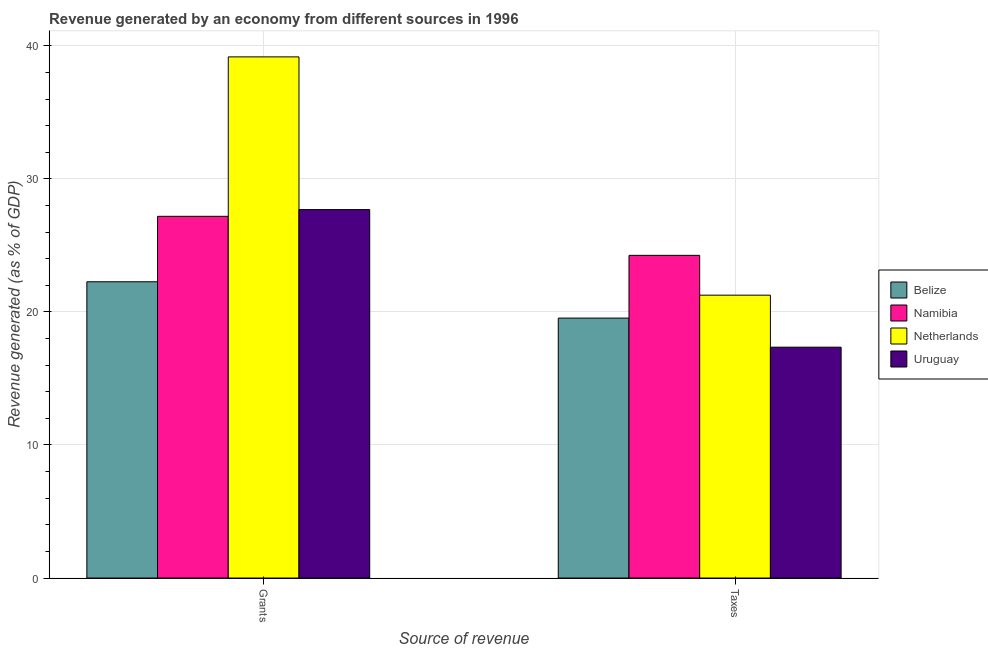What is the label of the 2nd group of bars from the left?
Keep it short and to the point. Taxes. What is the revenue generated by taxes in Namibia?
Make the answer very short. 24.25. Across all countries, what is the maximum revenue generated by taxes?
Make the answer very short. 24.25. Across all countries, what is the minimum revenue generated by taxes?
Ensure brevity in your answer.  17.35. In which country was the revenue generated by taxes maximum?
Your answer should be very brief. Namibia. In which country was the revenue generated by grants minimum?
Your answer should be very brief. Belize. What is the total revenue generated by grants in the graph?
Your answer should be compact. 116.32. What is the difference between the revenue generated by taxes in Belize and that in Namibia?
Provide a short and direct response. -4.71. What is the difference between the revenue generated by grants in Namibia and the revenue generated by taxes in Uruguay?
Your answer should be very brief. 9.84. What is the average revenue generated by taxes per country?
Your response must be concise. 20.6. What is the difference between the revenue generated by grants and revenue generated by taxes in Netherlands?
Your response must be concise. 17.91. What is the ratio of the revenue generated by grants in Belize to that in Netherlands?
Give a very brief answer. 0.57. Is the revenue generated by grants in Belize less than that in Uruguay?
Ensure brevity in your answer.  Yes. What does the 2nd bar from the left in Grants represents?
Offer a terse response. Namibia. What does the 3rd bar from the right in Taxes represents?
Your response must be concise. Namibia. How many bars are there?
Offer a terse response. 8. Are all the bars in the graph horizontal?
Provide a succinct answer. No. What is the difference between two consecutive major ticks on the Y-axis?
Keep it short and to the point. 10. Are the values on the major ticks of Y-axis written in scientific E-notation?
Ensure brevity in your answer.  No. Does the graph contain any zero values?
Provide a succinct answer. No. Does the graph contain grids?
Provide a short and direct response. Yes. How are the legend labels stacked?
Give a very brief answer. Vertical. What is the title of the graph?
Ensure brevity in your answer.  Revenue generated by an economy from different sources in 1996. Does "Middle East & North Africa (developing only)" appear as one of the legend labels in the graph?
Offer a very short reply. No. What is the label or title of the X-axis?
Provide a short and direct response. Source of revenue. What is the label or title of the Y-axis?
Provide a succinct answer. Revenue generated (as % of GDP). What is the Revenue generated (as % of GDP) of Belize in Grants?
Offer a terse response. 22.27. What is the Revenue generated (as % of GDP) of Namibia in Grants?
Give a very brief answer. 27.19. What is the Revenue generated (as % of GDP) in Netherlands in Grants?
Your answer should be very brief. 39.17. What is the Revenue generated (as % of GDP) in Uruguay in Grants?
Keep it short and to the point. 27.69. What is the Revenue generated (as % of GDP) in Belize in Taxes?
Ensure brevity in your answer.  19.54. What is the Revenue generated (as % of GDP) of Namibia in Taxes?
Give a very brief answer. 24.25. What is the Revenue generated (as % of GDP) of Netherlands in Taxes?
Keep it short and to the point. 21.26. What is the Revenue generated (as % of GDP) of Uruguay in Taxes?
Provide a succinct answer. 17.35. Across all Source of revenue, what is the maximum Revenue generated (as % of GDP) in Belize?
Your response must be concise. 22.27. Across all Source of revenue, what is the maximum Revenue generated (as % of GDP) in Namibia?
Keep it short and to the point. 27.19. Across all Source of revenue, what is the maximum Revenue generated (as % of GDP) in Netherlands?
Make the answer very short. 39.17. Across all Source of revenue, what is the maximum Revenue generated (as % of GDP) of Uruguay?
Offer a very short reply. 27.69. Across all Source of revenue, what is the minimum Revenue generated (as % of GDP) of Belize?
Give a very brief answer. 19.54. Across all Source of revenue, what is the minimum Revenue generated (as % of GDP) of Namibia?
Offer a terse response. 24.25. Across all Source of revenue, what is the minimum Revenue generated (as % of GDP) of Netherlands?
Offer a terse response. 21.26. Across all Source of revenue, what is the minimum Revenue generated (as % of GDP) of Uruguay?
Your response must be concise. 17.35. What is the total Revenue generated (as % of GDP) of Belize in the graph?
Give a very brief answer. 41.81. What is the total Revenue generated (as % of GDP) of Namibia in the graph?
Offer a very short reply. 51.44. What is the total Revenue generated (as % of GDP) in Netherlands in the graph?
Ensure brevity in your answer.  60.43. What is the total Revenue generated (as % of GDP) in Uruguay in the graph?
Provide a succinct answer. 45.04. What is the difference between the Revenue generated (as % of GDP) in Belize in Grants and that in Taxes?
Make the answer very short. 2.73. What is the difference between the Revenue generated (as % of GDP) of Namibia in Grants and that in Taxes?
Ensure brevity in your answer.  2.93. What is the difference between the Revenue generated (as % of GDP) of Netherlands in Grants and that in Taxes?
Offer a very short reply. 17.91. What is the difference between the Revenue generated (as % of GDP) in Uruguay in Grants and that in Taxes?
Offer a terse response. 10.34. What is the difference between the Revenue generated (as % of GDP) in Belize in Grants and the Revenue generated (as % of GDP) in Namibia in Taxes?
Your response must be concise. -1.99. What is the difference between the Revenue generated (as % of GDP) in Belize in Grants and the Revenue generated (as % of GDP) in Uruguay in Taxes?
Ensure brevity in your answer.  4.92. What is the difference between the Revenue generated (as % of GDP) of Namibia in Grants and the Revenue generated (as % of GDP) of Netherlands in Taxes?
Ensure brevity in your answer.  5.93. What is the difference between the Revenue generated (as % of GDP) in Namibia in Grants and the Revenue generated (as % of GDP) in Uruguay in Taxes?
Make the answer very short. 9.84. What is the difference between the Revenue generated (as % of GDP) of Netherlands in Grants and the Revenue generated (as % of GDP) of Uruguay in Taxes?
Offer a terse response. 21.82. What is the average Revenue generated (as % of GDP) of Belize per Source of revenue?
Keep it short and to the point. 20.9. What is the average Revenue generated (as % of GDP) of Namibia per Source of revenue?
Give a very brief answer. 25.72. What is the average Revenue generated (as % of GDP) of Netherlands per Source of revenue?
Keep it short and to the point. 30.22. What is the average Revenue generated (as % of GDP) in Uruguay per Source of revenue?
Your response must be concise. 22.52. What is the difference between the Revenue generated (as % of GDP) in Belize and Revenue generated (as % of GDP) in Namibia in Grants?
Offer a terse response. -4.92. What is the difference between the Revenue generated (as % of GDP) in Belize and Revenue generated (as % of GDP) in Netherlands in Grants?
Offer a terse response. -16.9. What is the difference between the Revenue generated (as % of GDP) of Belize and Revenue generated (as % of GDP) of Uruguay in Grants?
Your response must be concise. -5.42. What is the difference between the Revenue generated (as % of GDP) of Namibia and Revenue generated (as % of GDP) of Netherlands in Grants?
Offer a terse response. -11.98. What is the difference between the Revenue generated (as % of GDP) of Namibia and Revenue generated (as % of GDP) of Uruguay in Grants?
Offer a terse response. -0.51. What is the difference between the Revenue generated (as % of GDP) in Netherlands and Revenue generated (as % of GDP) in Uruguay in Grants?
Provide a succinct answer. 11.48. What is the difference between the Revenue generated (as % of GDP) in Belize and Revenue generated (as % of GDP) in Namibia in Taxes?
Offer a terse response. -4.71. What is the difference between the Revenue generated (as % of GDP) of Belize and Revenue generated (as % of GDP) of Netherlands in Taxes?
Give a very brief answer. -1.72. What is the difference between the Revenue generated (as % of GDP) in Belize and Revenue generated (as % of GDP) in Uruguay in Taxes?
Ensure brevity in your answer.  2.19. What is the difference between the Revenue generated (as % of GDP) in Namibia and Revenue generated (as % of GDP) in Netherlands in Taxes?
Your response must be concise. 2.99. What is the difference between the Revenue generated (as % of GDP) of Namibia and Revenue generated (as % of GDP) of Uruguay in Taxes?
Provide a short and direct response. 6.9. What is the difference between the Revenue generated (as % of GDP) in Netherlands and Revenue generated (as % of GDP) in Uruguay in Taxes?
Your answer should be compact. 3.91. What is the ratio of the Revenue generated (as % of GDP) of Belize in Grants to that in Taxes?
Your response must be concise. 1.14. What is the ratio of the Revenue generated (as % of GDP) in Namibia in Grants to that in Taxes?
Provide a short and direct response. 1.12. What is the ratio of the Revenue generated (as % of GDP) in Netherlands in Grants to that in Taxes?
Make the answer very short. 1.84. What is the ratio of the Revenue generated (as % of GDP) in Uruguay in Grants to that in Taxes?
Your response must be concise. 1.6. What is the difference between the highest and the second highest Revenue generated (as % of GDP) of Belize?
Ensure brevity in your answer.  2.73. What is the difference between the highest and the second highest Revenue generated (as % of GDP) of Namibia?
Offer a terse response. 2.93. What is the difference between the highest and the second highest Revenue generated (as % of GDP) of Netherlands?
Make the answer very short. 17.91. What is the difference between the highest and the second highest Revenue generated (as % of GDP) in Uruguay?
Ensure brevity in your answer.  10.34. What is the difference between the highest and the lowest Revenue generated (as % of GDP) of Belize?
Offer a terse response. 2.73. What is the difference between the highest and the lowest Revenue generated (as % of GDP) of Namibia?
Ensure brevity in your answer.  2.93. What is the difference between the highest and the lowest Revenue generated (as % of GDP) of Netherlands?
Give a very brief answer. 17.91. What is the difference between the highest and the lowest Revenue generated (as % of GDP) of Uruguay?
Offer a very short reply. 10.34. 